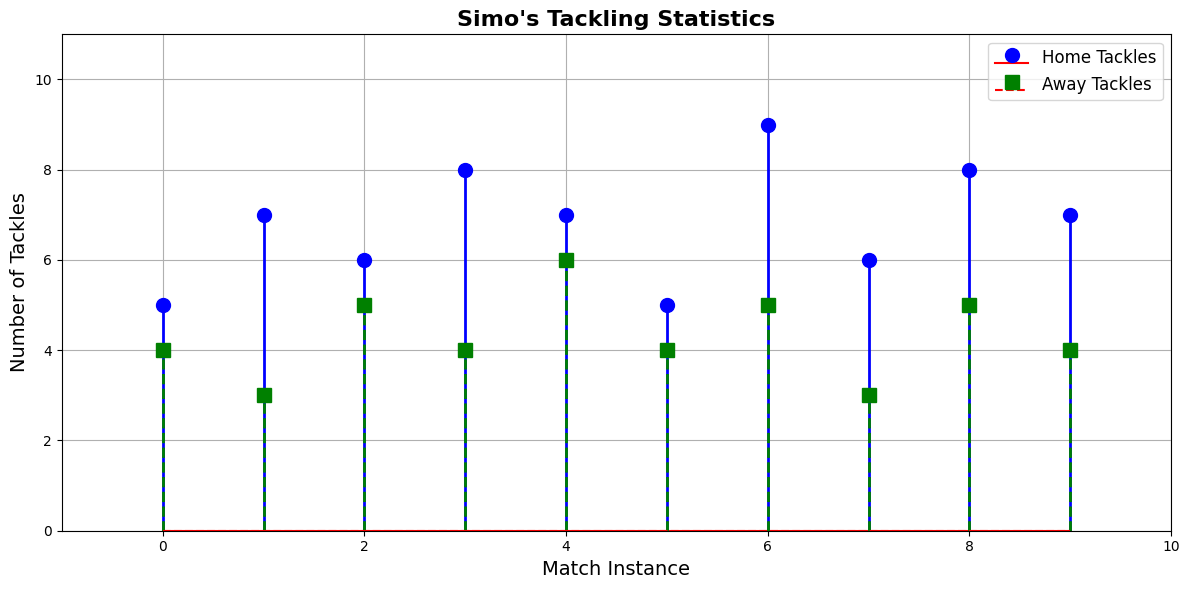What's the median number of tackles in home matches? To find the median, we need to arrange the home tackle values in ascending order: [5, 5, 6, 6, 7, 7, 7, 8, 8, 9]. The median is the middle value in this ordered list. Since there are 10 values, the median is the average of the 5th and 6th values: (7+7)/2.
Answer: 7 Which match type shows higher variability in tackles? Variability can be assessed by looking at the range and visual spread of data points. For home matches, the tackles range from 5 to 9; for away matches, they range from 3 to 6. The home match tackles show higher variability because their range (4) is larger than the range for away matches (3).
Answer: Home matches What's the sum of tackles in away matches? To find the sum, we add up all the away tackle values: 4 + 3 + 5 + 4 + 6 + 4 + 5 + 3 + 5 + 4 = 43.
Answer: 43 Which match type has the highest single instance of tackles and what is it? By looking at the stem plot, the tallest stem in the home section is 9, while in the away section, the tallest stem is 6. The highest single instance of tackles is in home matches with 9 tackles.
Answer: Home, 9 How many tackle instances are there in total? Total instances can be counted by summing the number of data points (stems) in both home and away sections. Home has 10 instances and away has 10 instances, making a total of 20 instances.
Answer: 20 What's the mean number of tackles in home matches? To calculate the mean, sum the home tackle values and divide by the number of instances. The sum is 5 + 7 + 6 + 8 + 7 + 5 + 9 + 6 + 8 + 7 = 68. There are 10 instances, so the mean is 68/10.
Answer: 6.8 How does the number of matches with 5 tackles compare for home and away games? We look at the number of stems labeled as 5. For home matches, there are two instances (5, 5). For away matches, there are three instances (5, 5, 5). There are more matches with 5 tackles in away games.
Answer: Away What is the difference between the highest and lowest number of tackles in home matches? The highest number of tackles in home matches is 9, and the lowest is 5. The difference is 9 - 5.
Answer: 4 Approximately, which match type shows more consistent performance? A consistent performance will have less variability. Looking at the spread of stem heights, away matches have values clustering tightly between 3 to 6, whereas home matches range from 5 to 9. Away matches show more consistent performance.
Answer: Away 